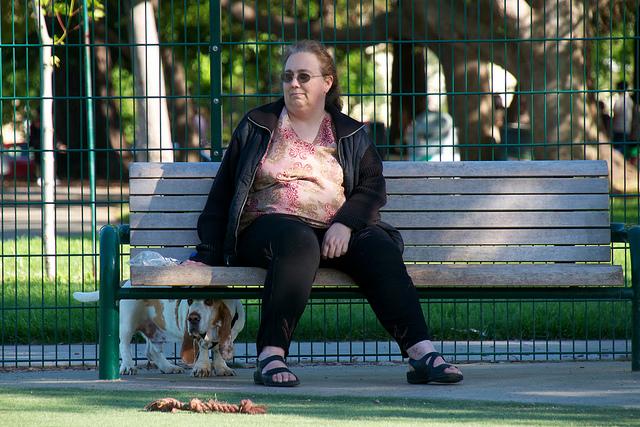Is the woman petting the dog under her?
Answer briefly. No. What kind of animal is beneath the bench?
Be succinct. Dog. What is lying on the ground in front of the dog?
Quick response, please. Rope. 